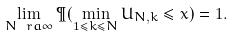Convert formula to latex. <formula><loc_0><loc_0><loc_500><loc_500>\lim _ { N \ r a \infty } \P ( \min _ { 1 \leq k \leq N } U _ { N , k } \leq x ) = 1 .</formula> 